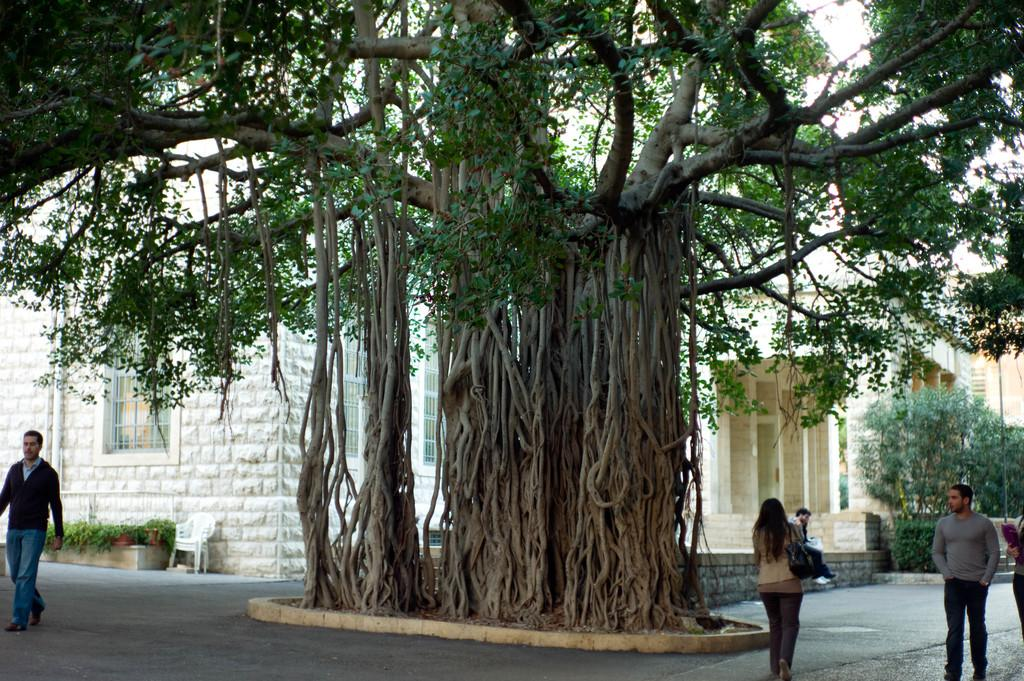What are the people in the image doing? There is a group of people walking on the road in the image. What can be seen in the background of the image? Trees, a fence, buildings, and the sky are visible in the image. What type of vegetation is present in the image? Houseplants are visible in the image. What type of furniture is present in the image? Chairs are present in the image. What time of day is the image likely taken? The image is likely taken during the day, as the sky is visible. What type of pancake is being distributed to the people in the image? There is no pancake present in the image, nor is there any indication of distribution. What book is the person in the image reading? There is no person reading a book in the image. 